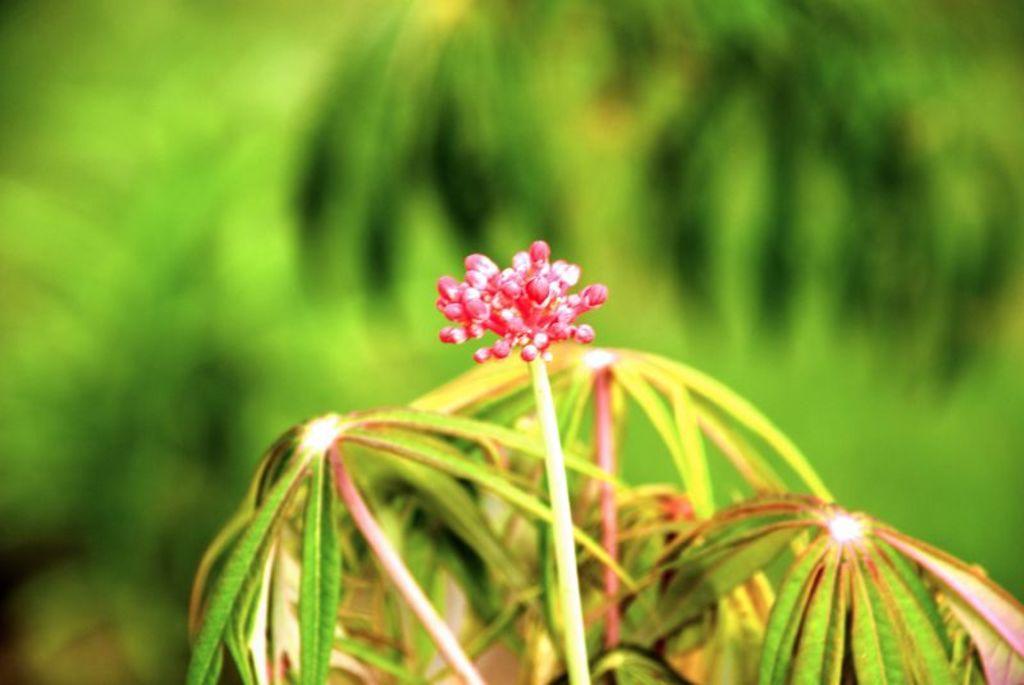Please provide a concise description of this image. In this picture we can see a flower, leaves and blurry background. 